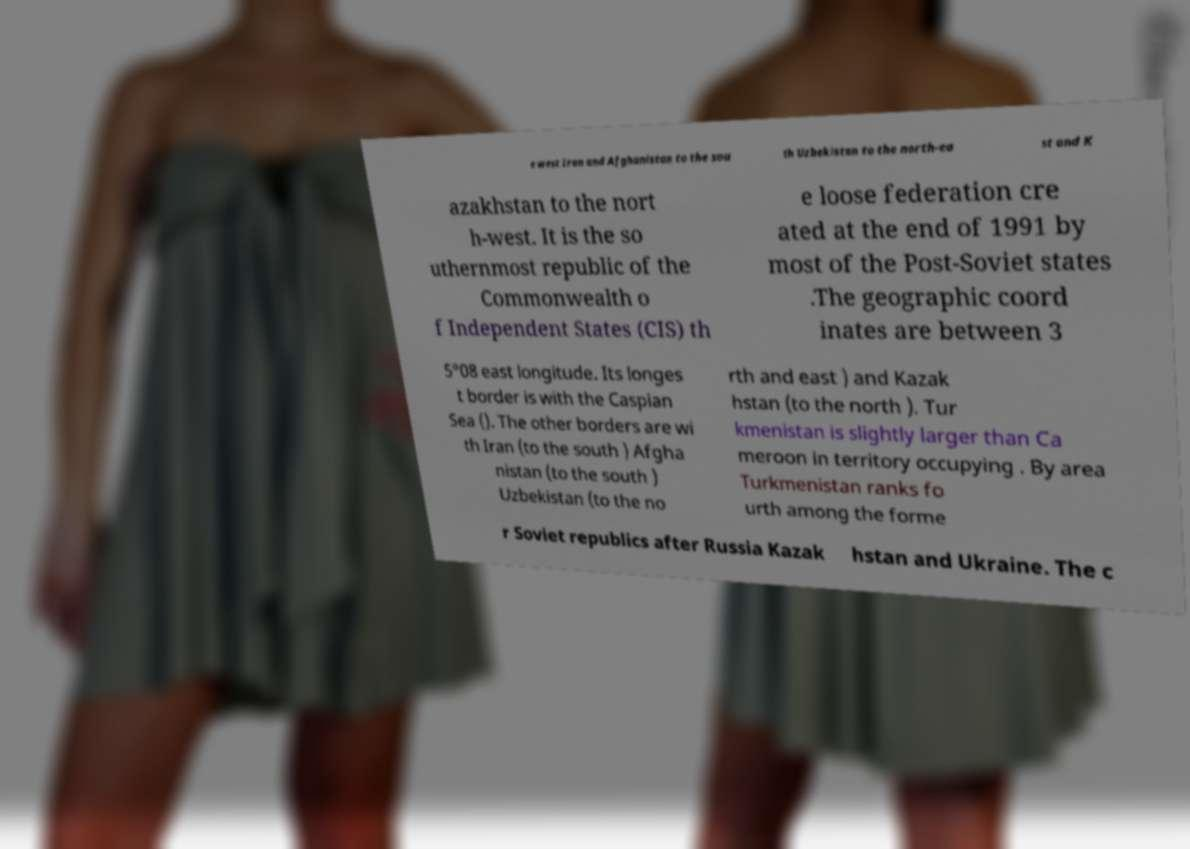Could you extract and type out the text from this image? e west Iran and Afghanistan to the sou th Uzbekistan to the north-ea st and K azakhstan to the nort h-west. It is the so uthernmost republic of the Commonwealth o f Independent States (CIS) th e loose federation cre ated at the end of 1991 by most of the Post-Soviet states .The geographic coord inates are between 3 5°08 east longitude. Its longes t border is with the Caspian Sea (). The other borders are wi th Iran (to the south ) Afgha nistan (to the south ) Uzbekistan (to the no rth and east ) and Kazak hstan (to the north ). Tur kmenistan is slightly larger than Ca meroon in territory occupying . By area Turkmenistan ranks fo urth among the forme r Soviet republics after Russia Kazak hstan and Ukraine. The c 